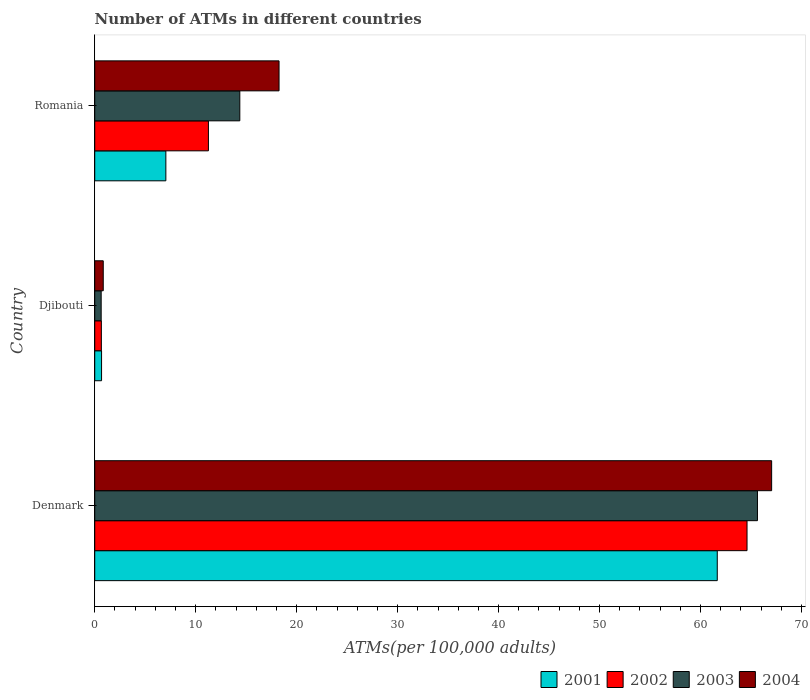How many groups of bars are there?
Your answer should be compact. 3. How many bars are there on the 1st tick from the top?
Offer a very short reply. 4. How many bars are there on the 2nd tick from the bottom?
Your answer should be very brief. 4. What is the label of the 2nd group of bars from the top?
Give a very brief answer. Djibouti. What is the number of ATMs in 2003 in Romania?
Offer a very short reply. 14.37. Across all countries, what is the maximum number of ATMs in 2003?
Keep it short and to the point. 65.64. Across all countries, what is the minimum number of ATMs in 2002?
Ensure brevity in your answer.  0.66. In which country was the number of ATMs in 2004 maximum?
Keep it short and to the point. Denmark. In which country was the number of ATMs in 2002 minimum?
Offer a very short reply. Djibouti. What is the total number of ATMs in 2001 in the graph?
Your response must be concise. 69.38. What is the difference between the number of ATMs in 2004 in Denmark and that in Djibouti?
Offer a terse response. 66.2. What is the difference between the number of ATMs in 2001 in Romania and the number of ATMs in 2003 in Djibouti?
Your response must be concise. 6.41. What is the average number of ATMs in 2003 per country?
Provide a succinct answer. 26.88. What is the difference between the number of ATMs in 2002 and number of ATMs in 2004 in Djibouti?
Your answer should be very brief. -0.19. In how many countries, is the number of ATMs in 2003 greater than 14 ?
Ensure brevity in your answer.  2. What is the ratio of the number of ATMs in 2004 in Djibouti to that in Romania?
Your answer should be very brief. 0.05. Is the number of ATMs in 2002 in Denmark less than that in Djibouti?
Ensure brevity in your answer.  No. Is the difference between the number of ATMs in 2002 in Djibouti and Romania greater than the difference between the number of ATMs in 2004 in Djibouti and Romania?
Keep it short and to the point. Yes. What is the difference between the highest and the second highest number of ATMs in 2002?
Provide a succinct answer. 53.35. What is the difference between the highest and the lowest number of ATMs in 2001?
Your answer should be compact. 60.98. In how many countries, is the number of ATMs in 2001 greater than the average number of ATMs in 2001 taken over all countries?
Give a very brief answer. 1. Is the sum of the number of ATMs in 2004 in Denmark and Romania greater than the maximum number of ATMs in 2003 across all countries?
Offer a very short reply. Yes. What does the 3rd bar from the top in Djibouti represents?
Give a very brief answer. 2002. What does the 3rd bar from the bottom in Denmark represents?
Provide a short and direct response. 2003. Are all the bars in the graph horizontal?
Make the answer very short. Yes. How many countries are there in the graph?
Ensure brevity in your answer.  3. Does the graph contain grids?
Make the answer very short. No. Where does the legend appear in the graph?
Provide a succinct answer. Bottom right. How many legend labels are there?
Offer a very short reply. 4. How are the legend labels stacked?
Your answer should be compact. Horizontal. What is the title of the graph?
Your answer should be very brief. Number of ATMs in different countries. What is the label or title of the X-axis?
Your response must be concise. ATMs(per 100,0 adults). What is the label or title of the Y-axis?
Provide a succinct answer. Country. What is the ATMs(per 100,000 adults) of 2001 in Denmark?
Your answer should be very brief. 61.66. What is the ATMs(per 100,000 adults) in 2002 in Denmark?
Keep it short and to the point. 64.61. What is the ATMs(per 100,000 adults) of 2003 in Denmark?
Provide a succinct answer. 65.64. What is the ATMs(per 100,000 adults) of 2004 in Denmark?
Provide a succinct answer. 67.04. What is the ATMs(per 100,000 adults) in 2001 in Djibouti?
Your response must be concise. 0.68. What is the ATMs(per 100,000 adults) in 2002 in Djibouti?
Make the answer very short. 0.66. What is the ATMs(per 100,000 adults) of 2003 in Djibouti?
Ensure brevity in your answer.  0.64. What is the ATMs(per 100,000 adults) of 2004 in Djibouti?
Your answer should be very brief. 0.84. What is the ATMs(per 100,000 adults) of 2001 in Romania?
Ensure brevity in your answer.  7.04. What is the ATMs(per 100,000 adults) of 2002 in Romania?
Your answer should be very brief. 11.26. What is the ATMs(per 100,000 adults) in 2003 in Romania?
Provide a succinct answer. 14.37. What is the ATMs(per 100,000 adults) of 2004 in Romania?
Make the answer very short. 18.26. Across all countries, what is the maximum ATMs(per 100,000 adults) of 2001?
Your response must be concise. 61.66. Across all countries, what is the maximum ATMs(per 100,000 adults) of 2002?
Ensure brevity in your answer.  64.61. Across all countries, what is the maximum ATMs(per 100,000 adults) in 2003?
Make the answer very short. 65.64. Across all countries, what is the maximum ATMs(per 100,000 adults) of 2004?
Offer a very short reply. 67.04. Across all countries, what is the minimum ATMs(per 100,000 adults) in 2001?
Provide a short and direct response. 0.68. Across all countries, what is the minimum ATMs(per 100,000 adults) in 2002?
Provide a short and direct response. 0.66. Across all countries, what is the minimum ATMs(per 100,000 adults) in 2003?
Your answer should be very brief. 0.64. Across all countries, what is the minimum ATMs(per 100,000 adults) of 2004?
Your answer should be very brief. 0.84. What is the total ATMs(per 100,000 adults) in 2001 in the graph?
Your response must be concise. 69.38. What is the total ATMs(per 100,000 adults) in 2002 in the graph?
Your answer should be very brief. 76.52. What is the total ATMs(per 100,000 adults) of 2003 in the graph?
Your response must be concise. 80.65. What is the total ATMs(per 100,000 adults) of 2004 in the graph?
Offer a terse response. 86.14. What is the difference between the ATMs(per 100,000 adults) of 2001 in Denmark and that in Djibouti?
Keep it short and to the point. 60.98. What is the difference between the ATMs(per 100,000 adults) in 2002 in Denmark and that in Djibouti?
Keep it short and to the point. 63.95. What is the difference between the ATMs(per 100,000 adults) of 2003 in Denmark and that in Djibouti?
Ensure brevity in your answer.  65. What is the difference between the ATMs(per 100,000 adults) in 2004 in Denmark and that in Djibouti?
Make the answer very short. 66.2. What is the difference between the ATMs(per 100,000 adults) in 2001 in Denmark and that in Romania?
Provide a short and direct response. 54.61. What is the difference between the ATMs(per 100,000 adults) of 2002 in Denmark and that in Romania?
Ensure brevity in your answer.  53.35. What is the difference between the ATMs(per 100,000 adults) in 2003 in Denmark and that in Romania?
Give a very brief answer. 51.27. What is the difference between the ATMs(per 100,000 adults) in 2004 in Denmark and that in Romania?
Provide a succinct answer. 48.79. What is the difference between the ATMs(per 100,000 adults) in 2001 in Djibouti and that in Romania?
Your response must be concise. -6.37. What is the difference between the ATMs(per 100,000 adults) in 2002 in Djibouti and that in Romania?
Provide a succinct answer. -10.6. What is the difference between the ATMs(per 100,000 adults) of 2003 in Djibouti and that in Romania?
Make the answer very short. -13.73. What is the difference between the ATMs(per 100,000 adults) of 2004 in Djibouti and that in Romania?
Provide a short and direct response. -17.41. What is the difference between the ATMs(per 100,000 adults) in 2001 in Denmark and the ATMs(per 100,000 adults) in 2002 in Djibouti?
Keep it short and to the point. 61. What is the difference between the ATMs(per 100,000 adults) of 2001 in Denmark and the ATMs(per 100,000 adults) of 2003 in Djibouti?
Your answer should be compact. 61.02. What is the difference between the ATMs(per 100,000 adults) of 2001 in Denmark and the ATMs(per 100,000 adults) of 2004 in Djibouti?
Provide a short and direct response. 60.81. What is the difference between the ATMs(per 100,000 adults) in 2002 in Denmark and the ATMs(per 100,000 adults) in 2003 in Djibouti?
Provide a short and direct response. 63.97. What is the difference between the ATMs(per 100,000 adults) of 2002 in Denmark and the ATMs(per 100,000 adults) of 2004 in Djibouti?
Offer a very short reply. 63.76. What is the difference between the ATMs(per 100,000 adults) in 2003 in Denmark and the ATMs(per 100,000 adults) in 2004 in Djibouti?
Offer a very short reply. 64.79. What is the difference between the ATMs(per 100,000 adults) of 2001 in Denmark and the ATMs(per 100,000 adults) of 2002 in Romania?
Make the answer very short. 50.4. What is the difference between the ATMs(per 100,000 adults) in 2001 in Denmark and the ATMs(per 100,000 adults) in 2003 in Romania?
Make the answer very short. 47.29. What is the difference between the ATMs(per 100,000 adults) of 2001 in Denmark and the ATMs(per 100,000 adults) of 2004 in Romania?
Provide a short and direct response. 43.4. What is the difference between the ATMs(per 100,000 adults) in 2002 in Denmark and the ATMs(per 100,000 adults) in 2003 in Romania?
Provide a short and direct response. 50.24. What is the difference between the ATMs(per 100,000 adults) of 2002 in Denmark and the ATMs(per 100,000 adults) of 2004 in Romania?
Your answer should be compact. 46.35. What is the difference between the ATMs(per 100,000 adults) of 2003 in Denmark and the ATMs(per 100,000 adults) of 2004 in Romania?
Provide a succinct answer. 47.38. What is the difference between the ATMs(per 100,000 adults) of 2001 in Djibouti and the ATMs(per 100,000 adults) of 2002 in Romania?
Your response must be concise. -10.58. What is the difference between the ATMs(per 100,000 adults) of 2001 in Djibouti and the ATMs(per 100,000 adults) of 2003 in Romania?
Your response must be concise. -13.69. What is the difference between the ATMs(per 100,000 adults) of 2001 in Djibouti and the ATMs(per 100,000 adults) of 2004 in Romania?
Offer a very short reply. -17.58. What is the difference between the ATMs(per 100,000 adults) in 2002 in Djibouti and the ATMs(per 100,000 adults) in 2003 in Romania?
Give a very brief answer. -13.71. What is the difference between the ATMs(per 100,000 adults) of 2002 in Djibouti and the ATMs(per 100,000 adults) of 2004 in Romania?
Provide a short and direct response. -17.6. What is the difference between the ATMs(per 100,000 adults) of 2003 in Djibouti and the ATMs(per 100,000 adults) of 2004 in Romania?
Offer a terse response. -17.62. What is the average ATMs(per 100,000 adults) of 2001 per country?
Make the answer very short. 23.13. What is the average ATMs(per 100,000 adults) in 2002 per country?
Offer a very short reply. 25.51. What is the average ATMs(per 100,000 adults) in 2003 per country?
Your answer should be very brief. 26.88. What is the average ATMs(per 100,000 adults) in 2004 per country?
Give a very brief answer. 28.71. What is the difference between the ATMs(per 100,000 adults) of 2001 and ATMs(per 100,000 adults) of 2002 in Denmark?
Keep it short and to the point. -2.95. What is the difference between the ATMs(per 100,000 adults) in 2001 and ATMs(per 100,000 adults) in 2003 in Denmark?
Provide a succinct answer. -3.98. What is the difference between the ATMs(per 100,000 adults) of 2001 and ATMs(per 100,000 adults) of 2004 in Denmark?
Ensure brevity in your answer.  -5.39. What is the difference between the ATMs(per 100,000 adults) of 2002 and ATMs(per 100,000 adults) of 2003 in Denmark?
Offer a terse response. -1.03. What is the difference between the ATMs(per 100,000 adults) in 2002 and ATMs(per 100,000 adults) in 2004 in Denmark?
Provide a short and direct response. -2.44. What is the difference between the ATMs(per 100,000 adults) of 2003 and ATMs(per 100,000 adults) of 2004 in Denmark?
Provide a succinct answer. -1.41. What is the difference between the ATMs(per 100,000 adults) of 2001 and ATMs(per 100,000 adults) of 2002 in Djibouti?
Your answer should be compact. 0.02. What is the difference between the ATMs(per 100,000 adults) in 2001 and ATMs(per 100,000 adults) in 2003 in Djibouti?
Keep it short and to the point. 0.04. What is the difference between the ATMs(per 100,000 adults) in 2001 and ATMs(per 100,000 adults) in 2004 in Djibouti?
Your response must be concise. -0.17. What is the difference between the ATMs(per 100,000 adults) of 2002 and ATMs(per 100,000 adults) of 2003 in Djibouti?
Offer a terse response. 0.02. What is the difference between the ATMs(per 100,000 adults) of 2002 and ATMs(per 100,000 adults) of 2004 in Djibouti?
Offer a very short reply. -0.19. What is the difference between the ATMs(per 100,000 adults) of 2003 and ATMs(per 100,000 adults) of 2004 in Djibouti?
Provide a succinct answer. -0.21. What is the difference between the ATMs(per 100,000 adults) in 2001 and ATMs(per 100,000 adults) in 2002 in Romania?
Your answer should be compact. -4.21. What is the difference between the ATMs(per 100,000 adults) in 2001 and ATMs(per 100,000 adults) in 2003 in Romania?
Offer a terse response. -7.32. What is the difference between the ATMs(per 100,000 adults) in 2001 and ATMs(per 100,000 adults) in 2004 in Romania?
Offer a terse response. -11.21. What is the difference between the ATMs(per 100,000 adults) in 2002 and ATMs(per 100,000 adults) in 2003 in Romania?
Give a very brief answer. -3.11. What is the difference between the ATMs(per 100,000 adults) in 2002 and ATMs(per 100,000 adults) in 2004 in Romania?
Offer a terse response. -7. What is the difference between the ATMs(per 100,000 adults) of 2003 and ATMs(per 100,000 adults) of 2004 in Romania?
Ensure brevity in your answer.  -3.89. What is the ratio of the ATMs(per 100,000 adults) in 2001 in Denmark to that in Djibouti?
Give a very brief answer. 91.18. What is the ratio of the ATMs(per 100,000 adults) of 2002 in Denmark to that in Djibouti?
Provide a succinct answer. 98.45. What is the ratio of the ATMs(per 100,000 adults) of 2003 in Denmark to that in Djibouti?
Your response must be concise. 102.88. What is the ratio of the ATMs(per 100,000 adults) of 2004 in Denmark to that in Djibouti?
Your answer should be very brief. 79.46. What is the ratio of the ATMs(per 100,000 adults) in 2001 in Denmark to that in Romania?
Make the answer very short. 8.75. What is the ratio of the ATMs(per 100,000 adults) of 2002 in Denmark to that in Romania?
Provide a succinct answer. 5.74. What is the ratio of the ATMs(per 100,000 adults) of 2003 in Denmark to that in Romania?
Make the answer very short. 4.57. What is the ratio of the ATMs(per 100,000 adults) in 2004 in Denmark to that in Romania?
Give a very brief answer. 3.67. What is the ratio of the ATMs(per 100,000 adults) in 2001 in Djibouti to that in Romania?
Offer a very short reply. 0.1. What is the ratio of the ATMs(per 100,000 adults) of 2002 in Djibouti to that in Romania?
Your answer should be compact. 0.06. What is the ratio of the ATMs(per 100,000 adults) in 2003 in Djibouti to that in Romania?
Keep it short and to the point. 0.04. What is the ratio of the ATMs(per 100,000 adults) of 2004 in Djibouti to that in Romania?
Ensure brevity in your answer.  0.05. What is the difference between the highest and the second highest ATMs(per 100,000 adults) in 2001?
Your answer should be compact. 54.61. What is the difference between the highest and the second highest ATMs(per 100,000 adults) in 2002?
Keep it short and to the point. 53.35. What is the difference between the highest and the second highest ATMs(per 100,000 adults) of 2003?
Make the answer very short. 51.27. What is the difference between the highest and the second highest ATMs(per 100,000 adults) of 2004?
Provide a succinct answer. 48.79. What is the difference between the highest and the lowest ATMs(per 100,000 adults) in 2001?
Ensure brevity in your answer.  60.98. What is the difference between the highest and the lowest ATMs(per 100,000 adults) of 2002?
Your answer should be very brief. 63.95. What is the difference between the highest and the lowest ATMs(per 100,000 adults) of 2003?
Your answer should be very brief. 65. What is the difference between the highest and the lowest ATMs(per 100,000 adults) of 2004?
Provide a short and direct response. 66.2. 